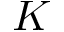<formula> <loc_0><loc_0><loc_500><loc_500>K</formula> 